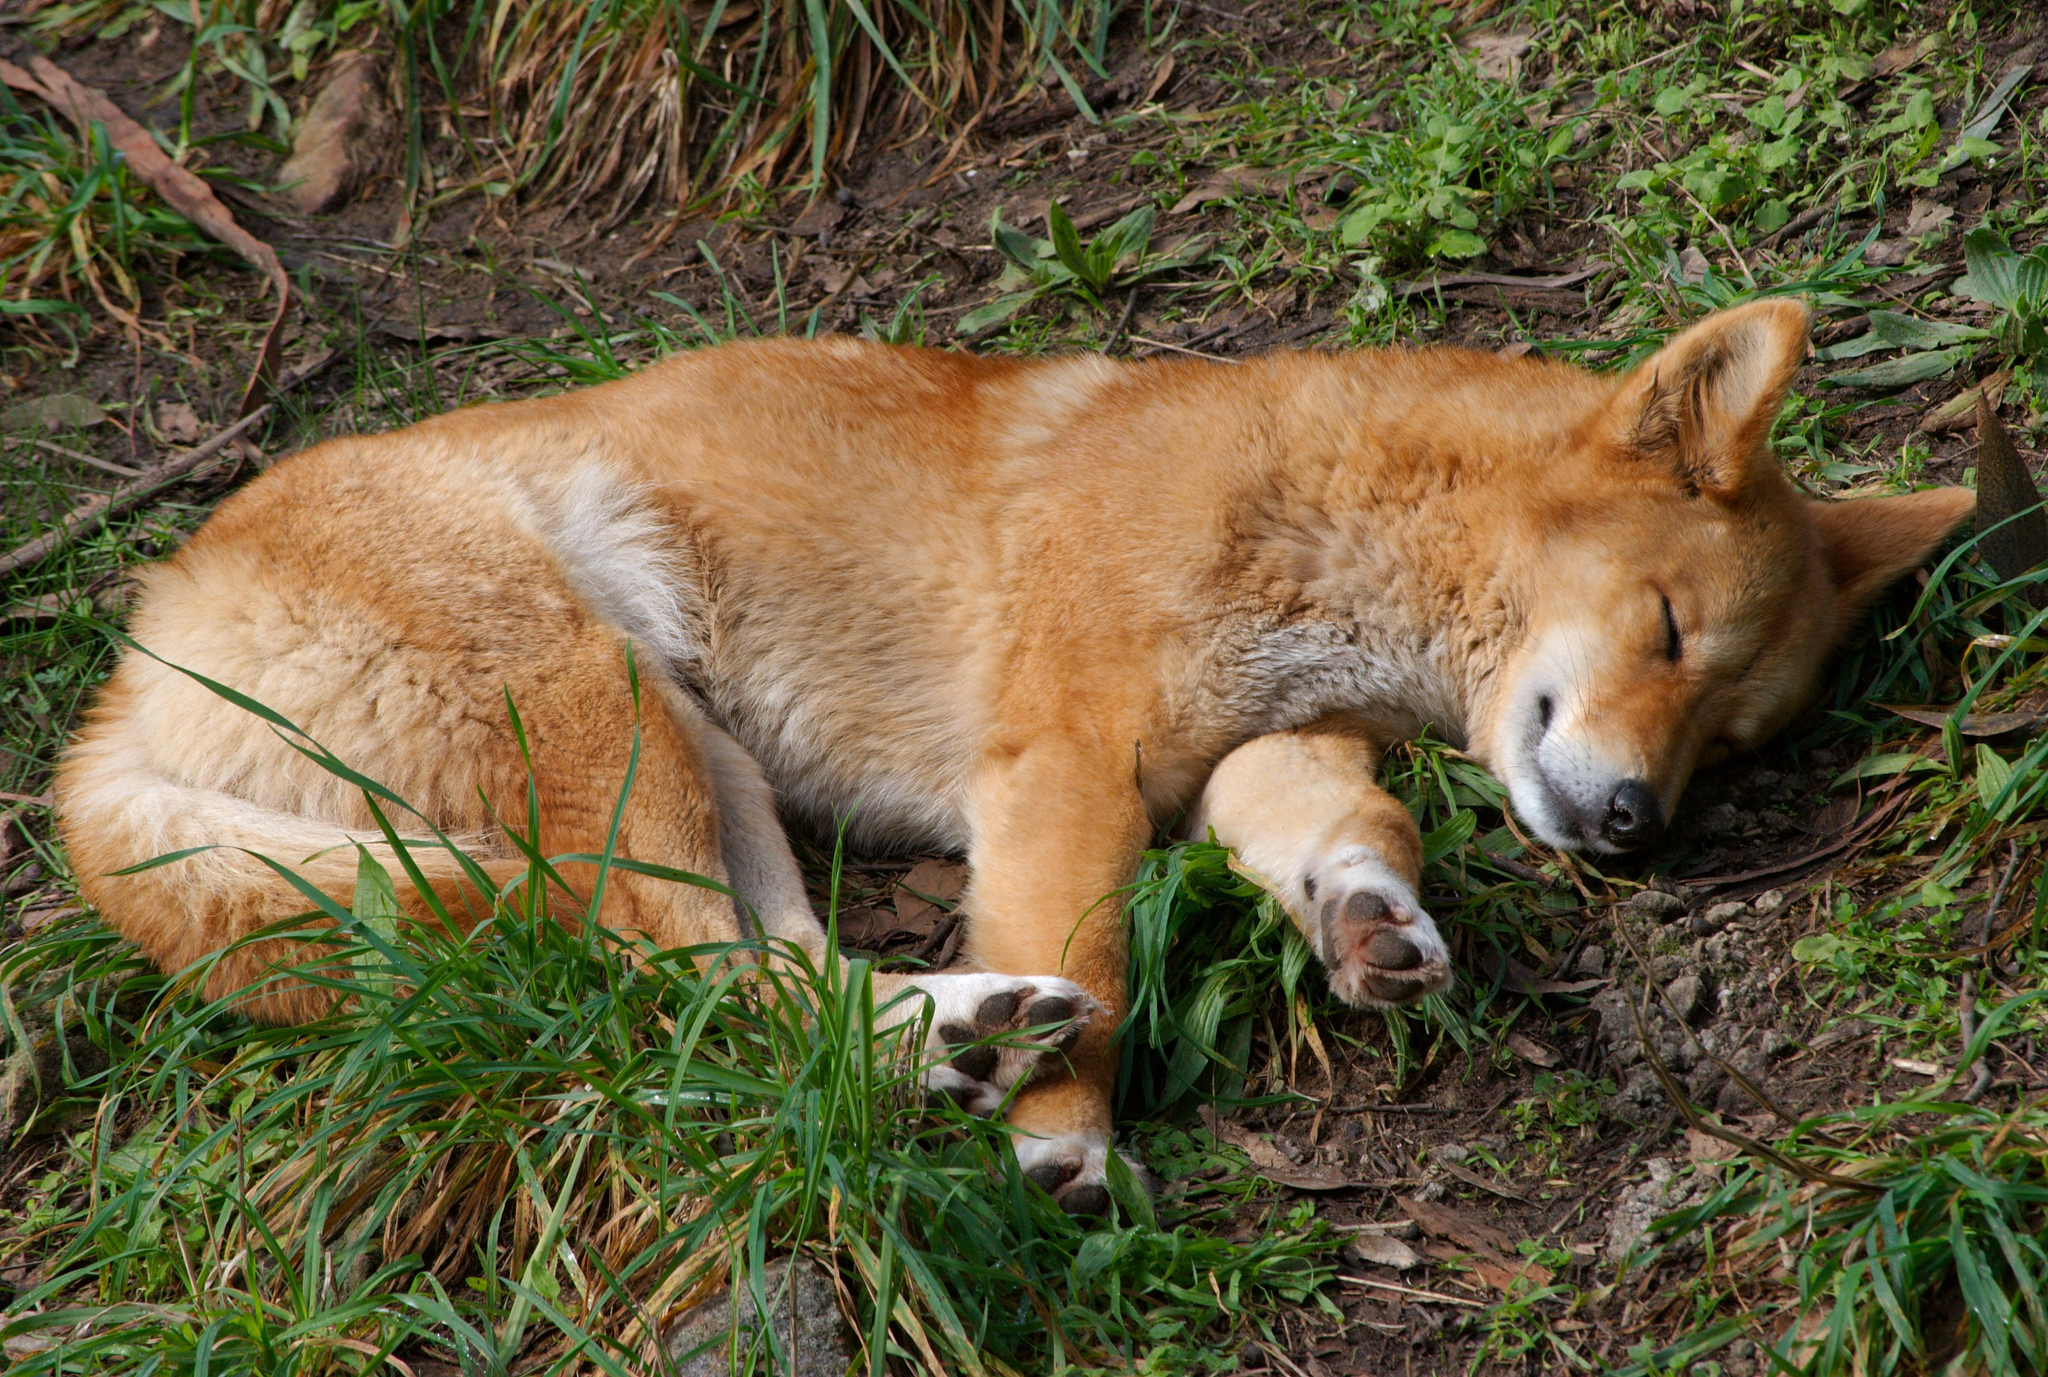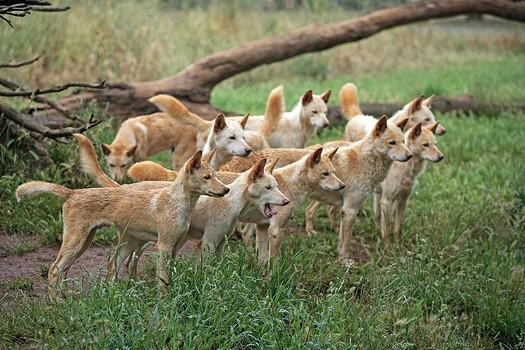The first image is the image on the left, the second image is the image on the right. Given the left and right images, does the statement "An image includes a dog sleeping on the ground." hold true? Answer yes or no. Yes. The first image is the image on the left, the second image is the image on the right. Considering the images on both sides, is "A single dog stands on a rock in the image on the right." valid? Answer yes or no. No. 